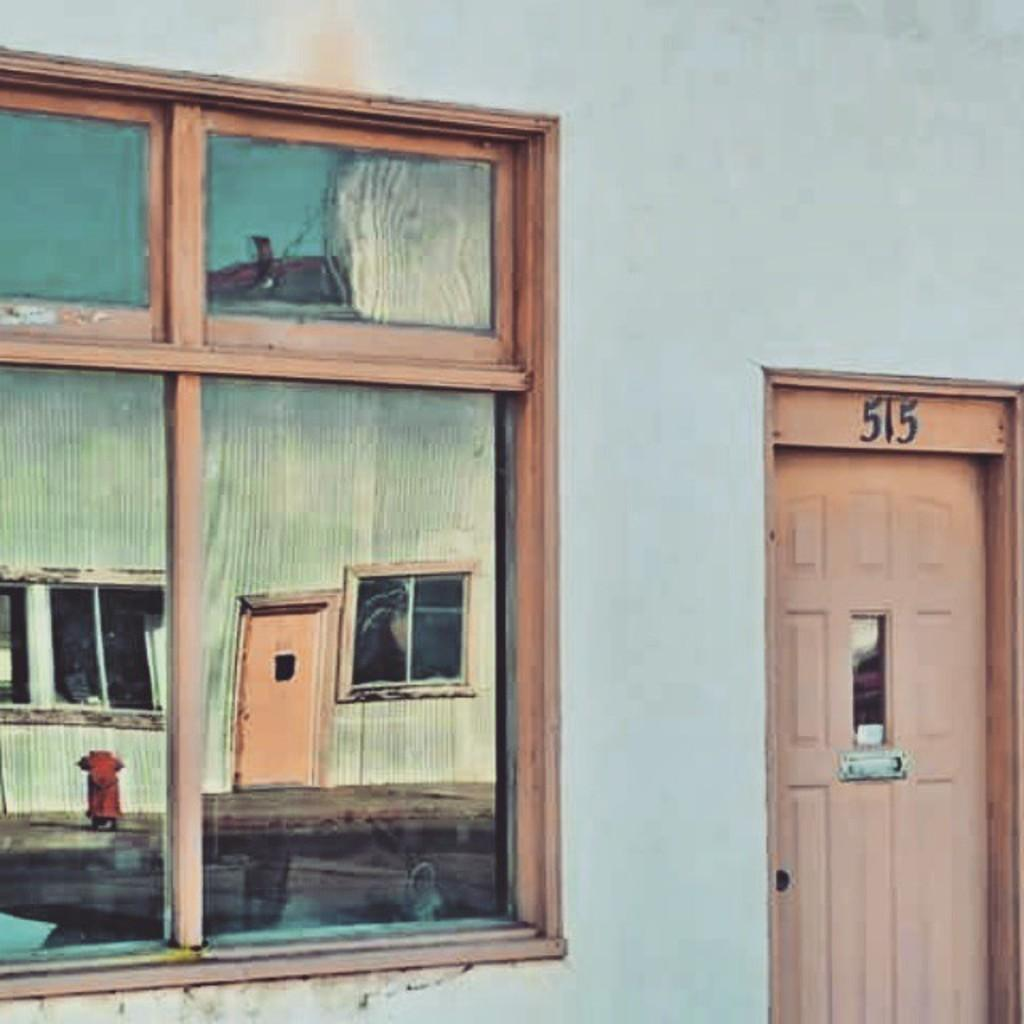What type of structure is visible in the image? There is a glass window, a door, and a wall visible in the image. What can be seen in the reflection of the glass window? The glass window has reflections of windows, doors, buildings, hydrants, and the sky. What type of behavior can be observed in the steel in the image? There is no steel present in the image, so it is not possible to observe any behavior. 